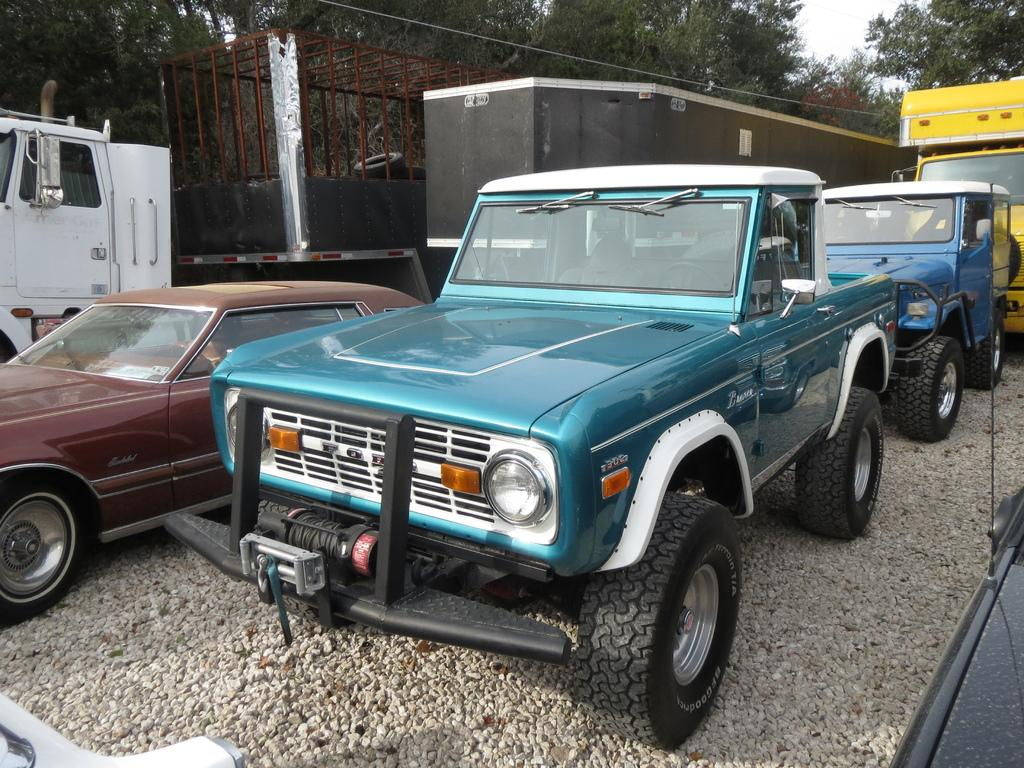What types of objects are present in the image? There are vehicles in the image. Can you describe the appearance of the vehicles? The vehicles are in different colors. What additional feature can be seen on one of the trucks? There is a cage on one of the trucks. What can be seen in the background of the image? There are trees visible at the top of the image. How does the bomb explode in the image? There is no bomb present in the image, so it cannot explode. Can you describe the direction in which the vehicles are moving in the image? The image is still, so the vehicles are not moving. 